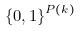<formula> <loc_0><loc_0><loc_500><loc_500>\{ 0 , 1 \} ^ { P ( k ) }</formula> 